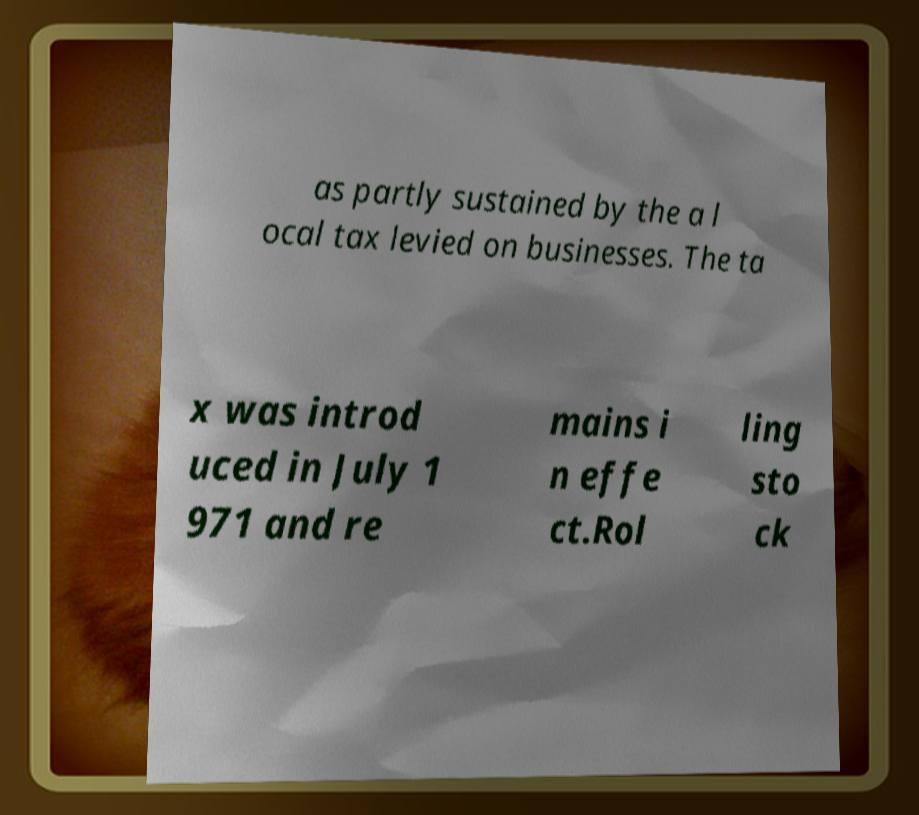Please read and relay the text visible in this image. What does it say? as partly sustained by the a l ocal tax levied on businesses. The ta x was introd uced in July 1 971 and re mains i n effe ct.Rol ling sto ck 